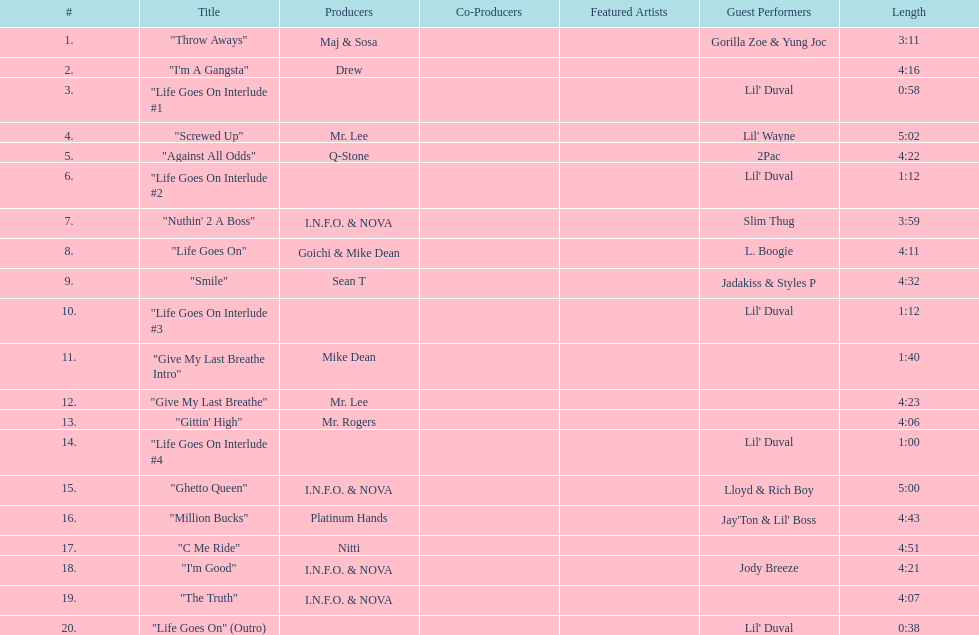How many tracks on trae's album "life goes on"? 20. 